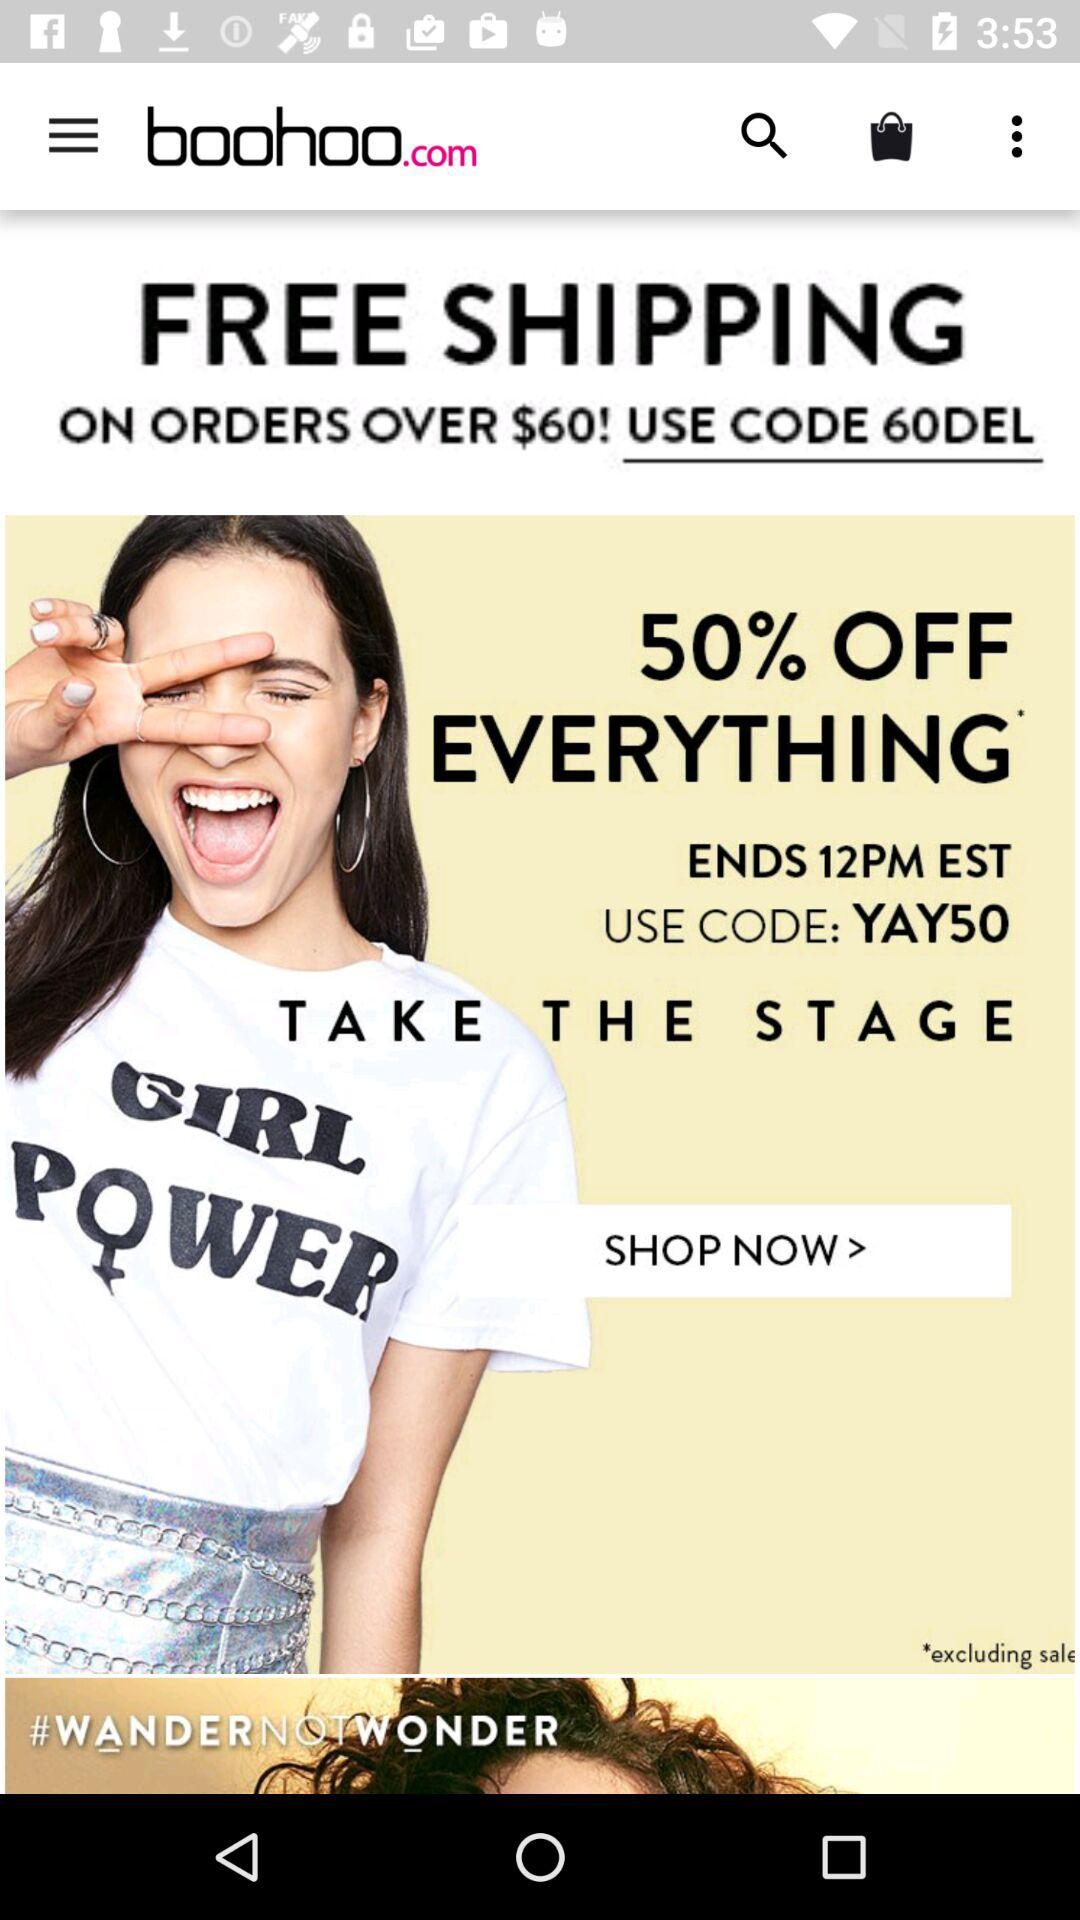What is the off percentage on everything? The off percentage on everything is 50. 